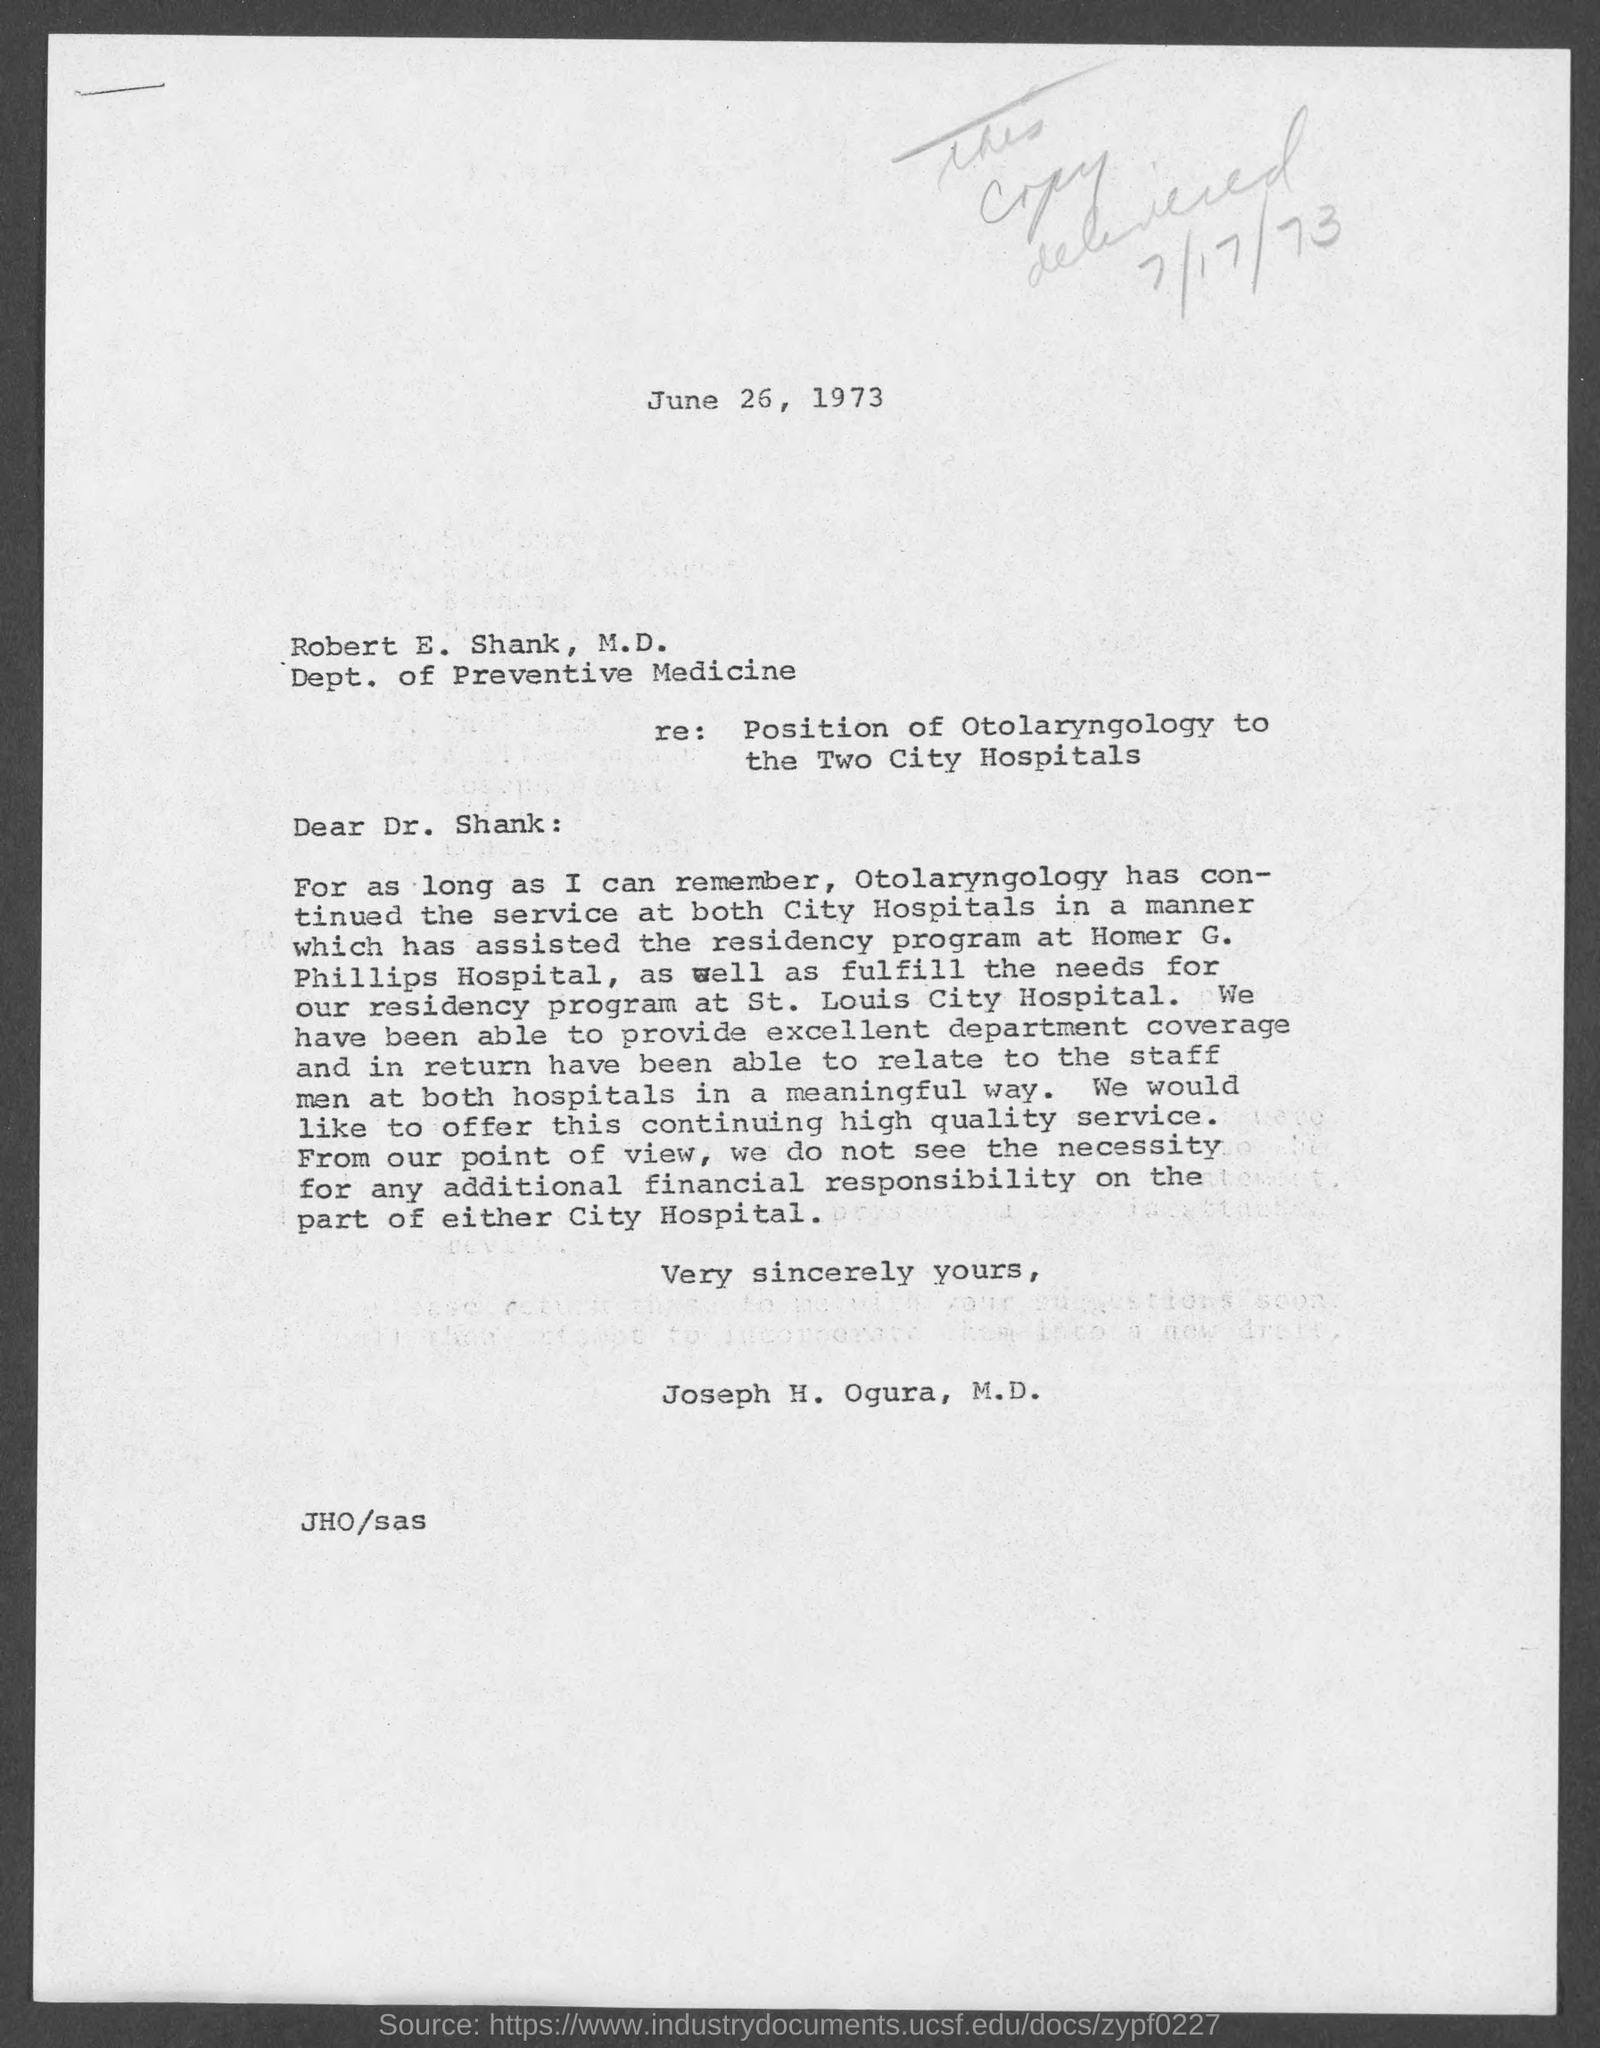What is the issued date of this letter?
Provide a short and direct response. June 26, 1973. Who is the sender of this letter?
Offer a terse response. Joseph H. Ogura, M.D. 